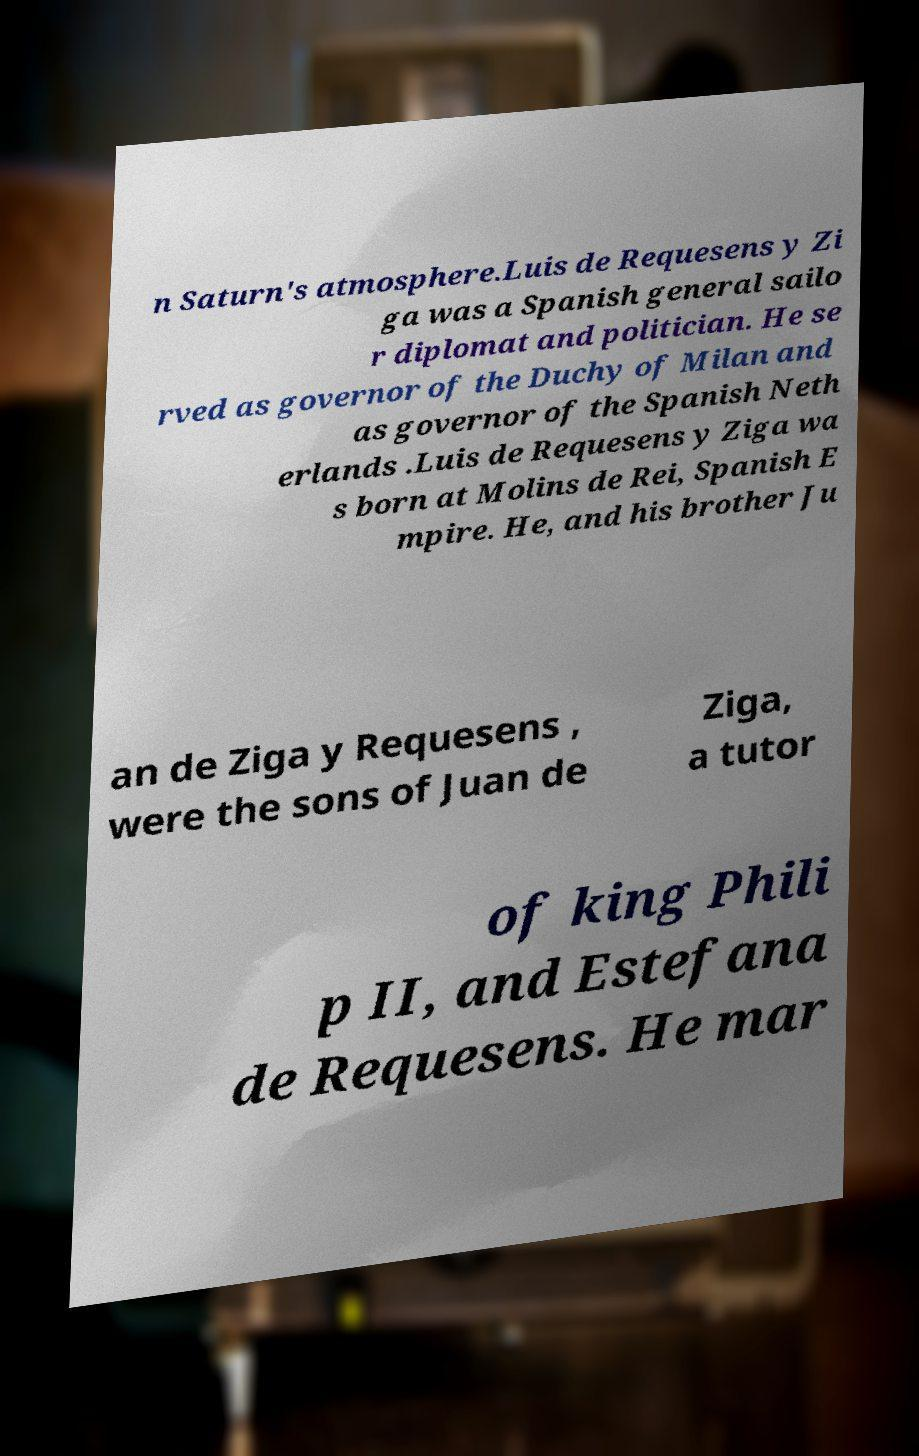Could you extract and type out the text from this image? n Saturn's atmosphere.Luis de Requesens y Zi ga was a Spanish general sailo r diplomat and politician. He se rved as governor of the Duchy of Milan and as governor of the Spanish Neth erlands .Luis de Requesens y Ziga wa s born at Molins de Rei, Spanish E mpire. He, and his brother Ju an de Ziga y Requesens , were the sons of Juan de Ziga, a tutor of king Phili p II, and Estefana de Requesens. He mar 